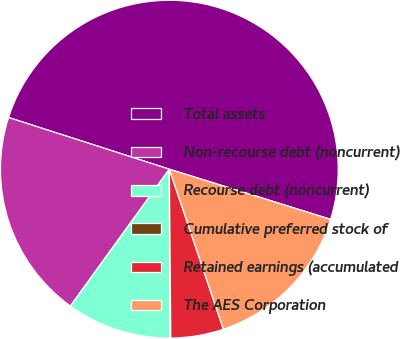Convert chart to OTSL. <chart><loc_0><loc_0><loc_500><loc_500><pie_chart><fcel>Total assets<fcel>Non-recourse debt (noncurrent)<fcel>Recourse debt (noncurrent)<fcel>Cumulative preferred stock of<fcel>Retained earnings (accumulated<fcel>The AES Corporation<nl><fcel>49.85%<fcel>19.99%<fcel>10.03%<fcel>0.07%<fcel>5.05%<fcel>15.01%<nl></chart> 